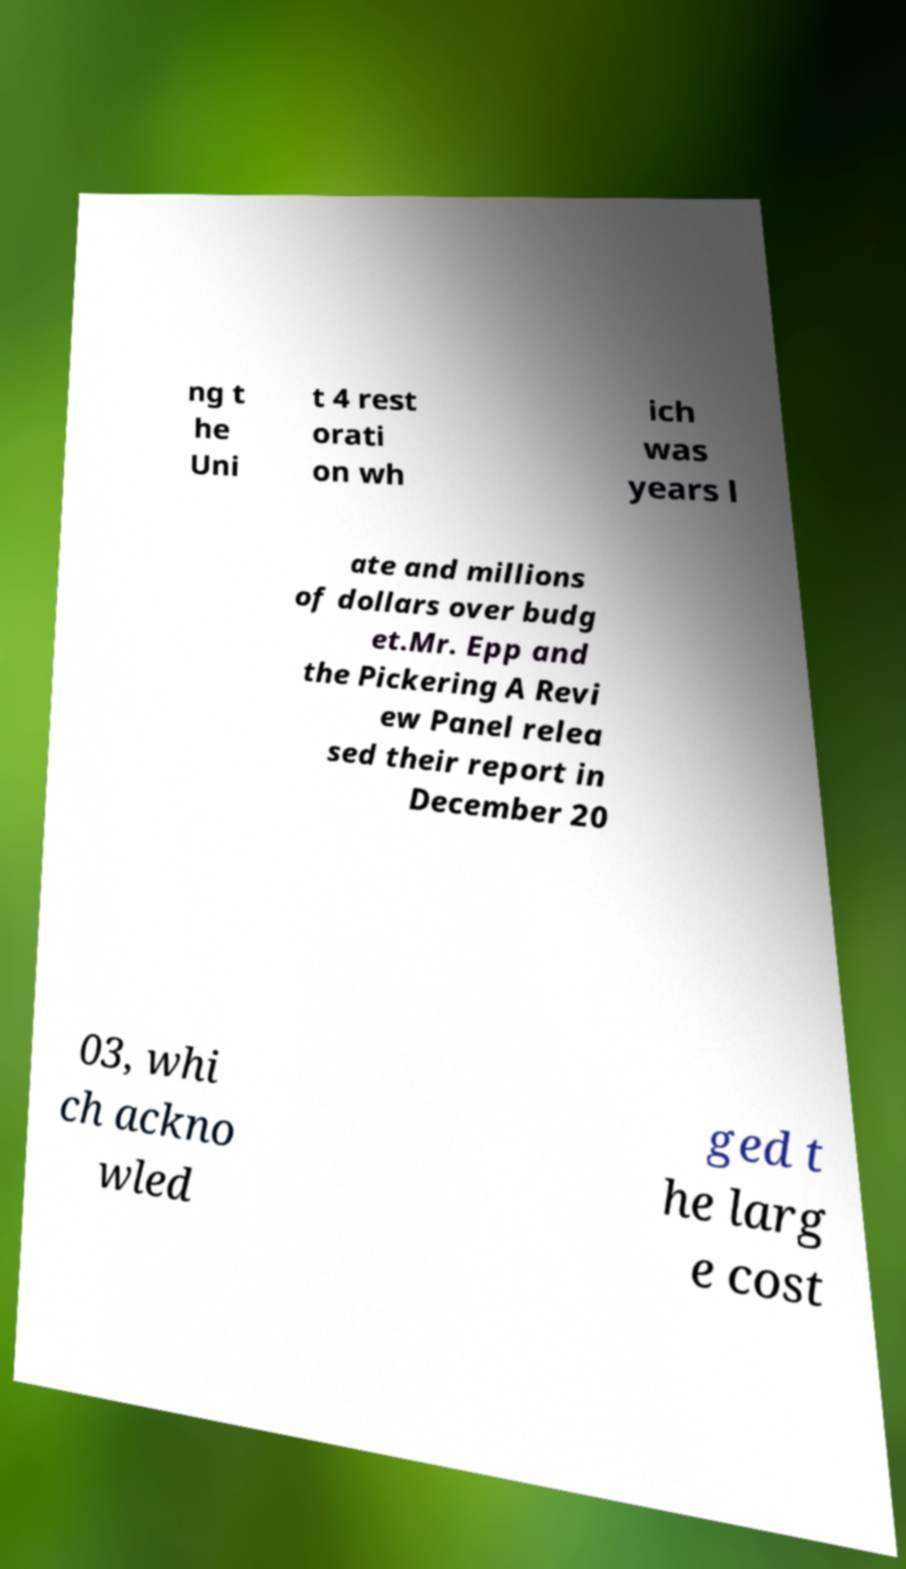I need the written content from this picture converted into text. Can you do that? ng t he Uni t 4 rest orati on wh ich was years l ate and millions of dollars over budg et.Mr. Epp and the Pickering A Revi ew Panel relea sed their report in December 20 03, whi ch ackno wled ged t he larg e cost 